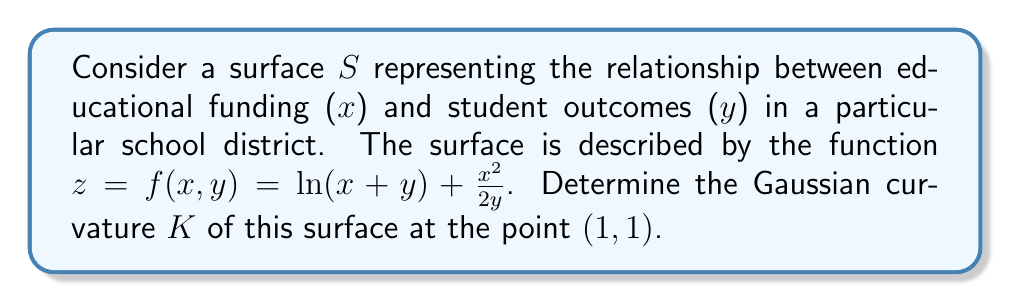Provide a solution to this math problem. To find the Gaussian curvature, we need to calculate the first and second fundamental forms of the surface.

Step 1: Calculate the partial derivatives
$$f_x = \frac{1}{x+y} + \frac{x}{y}$$
$$f_y = \frac{1}{x+y} - \frac{x^2}{2y^2}$$
$$f_{xx} = -\frac{1}{(x+y)^2} + \frac{1}{y}$$
$$f_{xy} = -\frac{1}{(x+y)^2}$$
$$f_{yy} = -\frac{1}{(x+y)^2} + \frac{x^2}{y^3}$$

Step 2: Calculate the coefficients of the first fundamental form
$$E = 1 + f_x^2$$
$$F = f_x f_y$$
$$G = 1 + f_y^2$$

Step 3: Calculate the coefficients of the second fundamental form
$$e = \frac{f_{xx}}{\sqrt{1 + f_x^2 + f_y^2}}$$
$$f = \frac{f_{xy}}{\sqrt{1 + f_x^2 + f_y^2}}$$
$$g = \frac{f_{yy}}{\sqrt{1 + f_x^2 + f_y^2}}$$

Step 4: Calculate the Gaussian curvature
$$K = \frac{eg - f^2}{EG - F^2}$$

Step 5: Evaluate at the point (1, 1)
Substituting x = 1 and y = 1 into all the expressions:

$$f_x = \frac{1}{2} + 1 = \frac{3}{2}$$
$$f_y = \frac{1}{2} - \frac{1}{2} = 0$$
$$f_{xx} = -\frac{1}{4} + 1 = \frac{3}{4}$$
$$f_{xy} = -\frac{1}{4}$$
$$f_{yy} = -\frac{1}{4} + 1 = \frac{3}{4}$$

$$E = 1 + (\frac{3}{2})^2 = \frac{13}{4}$$
$$F = \frac{3}{2} \cdot 0 = 0$$
$$G = 1 + 0^2 = 1$$

$$e = \frac{\frac{3}{4}}{\sqrt{1 + (\frac{3}{2})^2 + 0^2}} = \frac{3}{2\sqrt{13}}$$
$$f = \frac{-\frac{1}{4}}{\sqrt{1 + (\frac{3}{2})^2 + 0^2}} = -\frac{1}{2\sqrt{13}}$$
$$g = \frac{\frac{3}{4}}{\sqrt{1 + (\frac{3}{2})^2 + 0^2}} = \frac{3}{2\sqrt{13}}$$

Now, we can calculate the Gaussian curvature:

$$K = \frac{(\frac{3}{2\sqrt{13}})(\frac{3}{2\sqrt{13}}) - (-\frac{1}{2\sqrt{13}})^2}{(\frac{13}{4})(1) - 0^2} = \frac{9}{52} - \frac{1}{52} = \frac{2}{13}$$
Answer: $K = \frac{2}{13}$ 